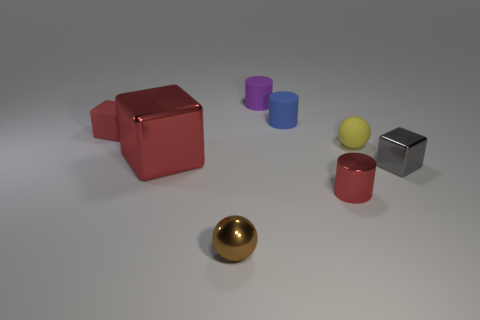Subtract all brown cubes. Subtract all cyan cylinders. How many cubes are left? 3 Subtract all red balls. How many brown blocks are left? 0 Add 6 small cyans. How many small yellows exist? 0 Subtract all green matte spheres. Subtract all tiny gray things. How many objects are left? 7 Add 3 rubber spheres. How many rubber spheres are left? 4 Add 4 small brown spheres. How many small brown spheres exist? 5 Add 1 matte blocks. How many objects exist? 9 Subtract all gray cubes. How many cubes are left? 2 Subtract all red shiny cylinders. How many cylinders are left? 2 Subtract 1 red blocks. How many objects are left? 7 